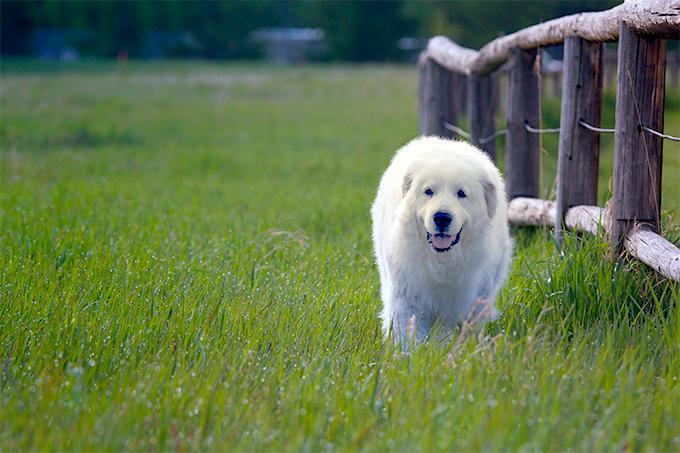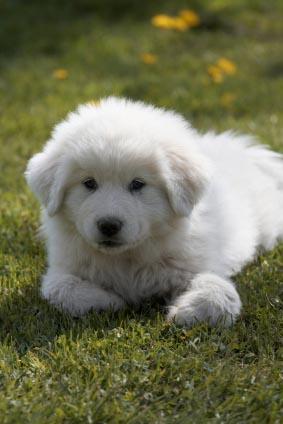The first image is the image on the left, the second image is the image on the right. Analyze the images presented: Is the assertion "A full sized dog is sitting with its legs extended on the ground" valid? Answer yes or no. No. 